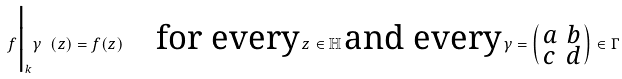Convert formula to latex. <formula><loc_0><loc_0><loc_500><loc_500>f \Big | _ { k } \gamma \ ( z ) = f ( z ) \quad \text {for every} \, z \in \mathbb { H } \, \text {and every} \, \gamma = \left ( \begin{smallmatrix} a & b \\ c & d \end{smallmatrix} \right ) \in \Gamma</formula> 